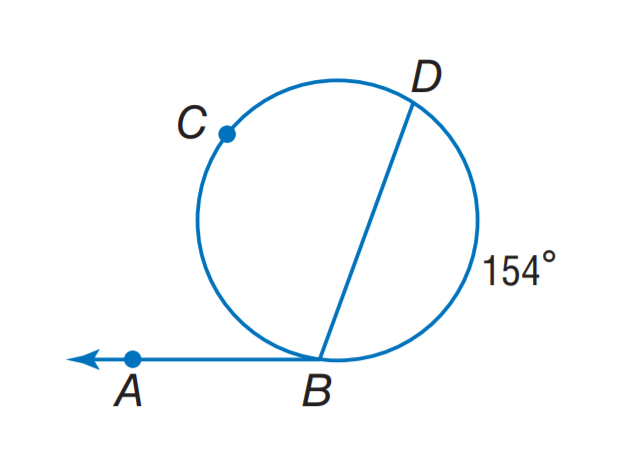Question: Find m \angle A B D.
Choices:
A. 97
B. 103
C. 126
D. 154
Answer with the letter. Answer: B 